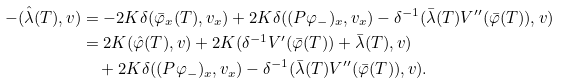<formula> <loc_0><loc_0><loc_500><loc_500>- ( \hat { \lambda } ( T ) , v ) & = - 2 K \delta ( \bar { \varphi } _ { x } ( T ) , v _ { x } ) + 2 K \delta ( ( P \varphi _ { - } ) _ { x } , v _ { x } ) - \delta ^ { - 1 } ( \bar { \lambda } ( T ) V ^ { \prime \prime } ( \bar { \varphi } ( T ) ) , v ) \\ & = 2 K ( \hat { \varphi } ( T ) , v ) + 2 K ( \delta ^ { - 1 } V ^ { \prime } ( \bar { \varphi } ( T ) ) + \bar { \lambda } ( T ) , v ) \\ & \quad + 2 K \delta ( ( P \varphi _ { - } ) _ { x } , v _ { x } ) - \delta ^ { - 1 } ( \bar { \lambda } ( T ) V ^ { \prime \prime } ( \bar { \varphi } ( T ) ) , v ) .</formula> 